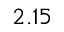Convert formula to latex. <formula><loc_0><loc_0><loc_500><loc_500>2 . 1 5</formula> 